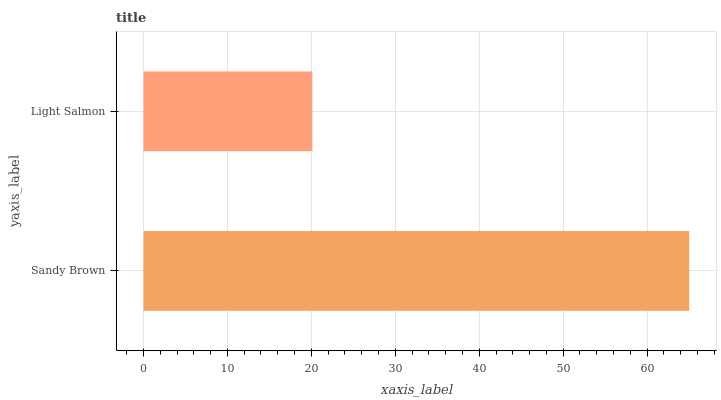Is Light Salmon the minimum?
Answer yes or no. Yes. Is Sandy Brown the maximum?
Answer yes or no. Yes. Is Light Salmon the maximum?
Answer yes or no. No. Is Sandy Brown greater than Light Salmon?
Answer yes or no. Yes. Is Light Salmon less than Sandy Brown?
Answer yes or no. Yes. Is Light Salmon greater than Sandy Brown?
Answer yes or no. No. Is Sandy Brown less than Light Salmon?
Answer yes or no. No. Is Sandy Brown the high median?
Answer yes or no. Yes. Is Light Salmon the low median?
Answer yes or no. Yes. Is Light Salmon the high median?
Answer yes or no. No. Is Sandy Brown the low median?
Answer yes or no. No. 